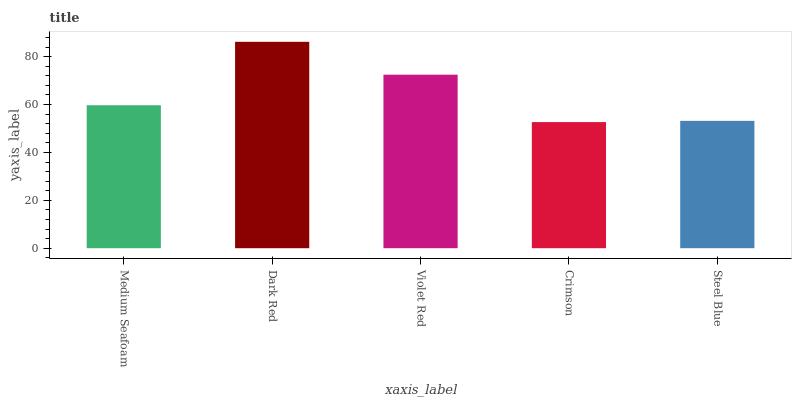Is Crimson the minimum?
Answer yes or no. Yes. Is Dark Red the maximum?
Answer yes or no. Yes. Is Violet Red the minimum?
Answer yes or no. No. Is Violet Red the maximum?
Answer yes or no. No. Is Dark Red greater than Violet Red?
Answer yes or no. Yes. Is Violet Red less than Dark Red?
Answer yes or no. Yes. Is Violet Red greater than Dark Red?
Answer yes or no. No. Is Dark Red less than Violet Red?
Answer yes or no. No. Is Medium Seafoam the high median?
Answer yes or no. Yes. Is Medium Seafoam the low median?
Answer yes or no. Yes. Is Dark Red the high median?
Answer yes or no. No. Is Dark Red the low median?
Answer yes or no. No. 